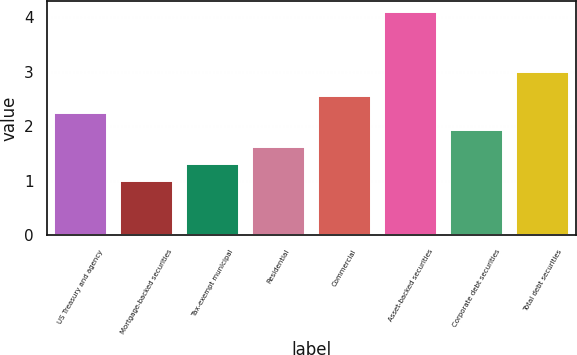<chart> <loc_0><loc_0><loc_500><loc_500><bar_chart><fcel>US Treasury and agency<fcel>Mortgage-backed securities<fcel>Tax-exempt municipal<fcel>Residential<fcel>Commercial<fcel>Asset-backed securities<fcel>Corporate debt securities<fcel>Total debt securities<nl><fcel>2.24<fcel>1<fcel>1.31<fcel>1.62<fcel>2.55<fcel>4.09<fcel>1.93<fcel>3<nl></chart> 